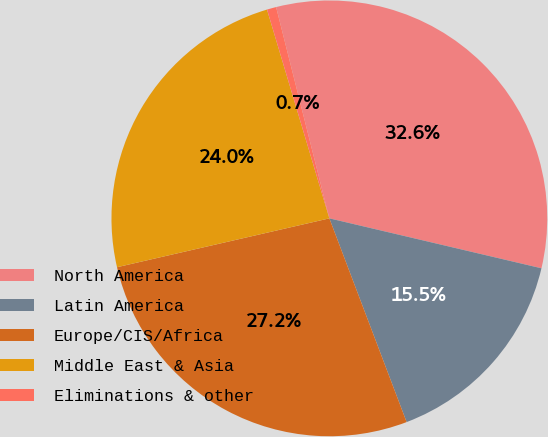Convert chart to OTSL. <chart><loc_0><loc_0><loc_500><loc_500><pie_chart><fcel>North America<fcel>Latin America<fcel>Europe/CIS/Africa<fcel>Middle East & Asia<fcel>Eliminations & other<nl><fcel>32.61%<fcel>15.55%<fcel>27.17%<fcel>23.98%<fcel>0.69%<nl></chart> 